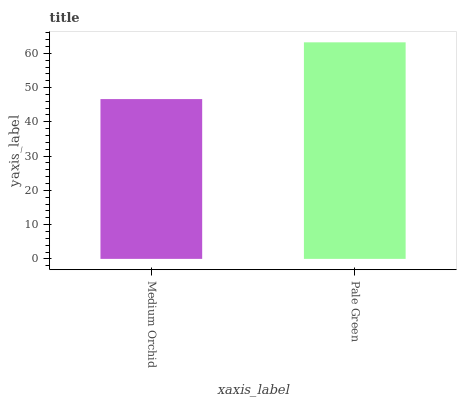Is Medium Orchid the minimum?
Answer yes or no. Yes. Is Pale Green the maximum?
Answer yes or no. Yes. Is Pale Green the minimum?
Answer yes or no. No. Is Pale Green greater than Medium Orchid?
Answer yes or no. Yes. Is Medium Orchid less than Pale Green?
Answer yes or no. Yes. Is Medium Orchid greater than Pale Green?
Answer yes or no. No. Is Pale Green less than Medium Orchid?
Answer yes or no. No. Is Pale Green the high median?
Answer yes or no. Yes. Is Medium Orchid the low median?
Answer yes or no. Yes. Is Medium Orchid the high median?
Answer yes or no. No. Is Pale Green the low median?
Answer yes or no. No. 